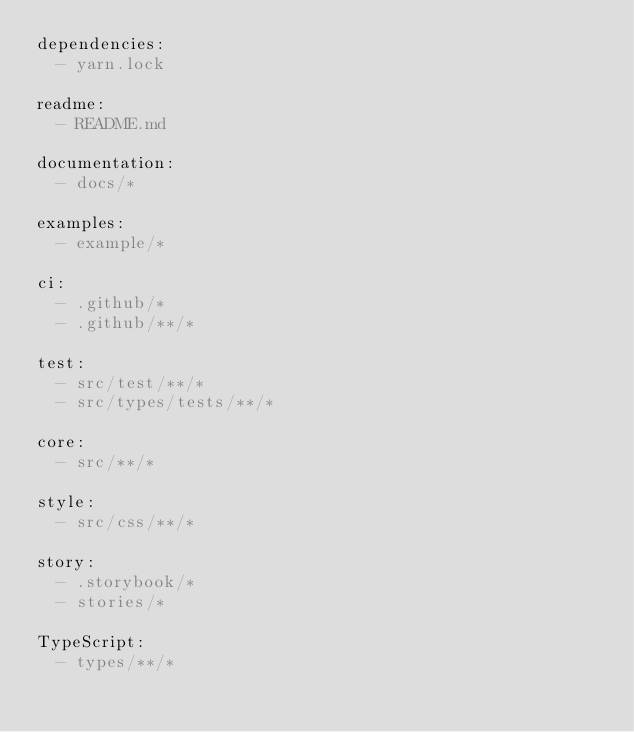Convert code to text. <code><loc_0><loc_0><loc_500><loc_500><_YAML_>dependencies:
  - yarn.lock

readme:
  - README.md

documentation:
  - docs/*

examples:
  - example/*

ci:
  - .github/*
  - .github/**/*

test:
  - src/test/**/*
  - src/types/tests/**/*

core:
  - src/**/*

style:
  - src/css/**/*

story:
  - .storybook/*
  - stories/*

TypeScript:
  - types/**/*
</code> 